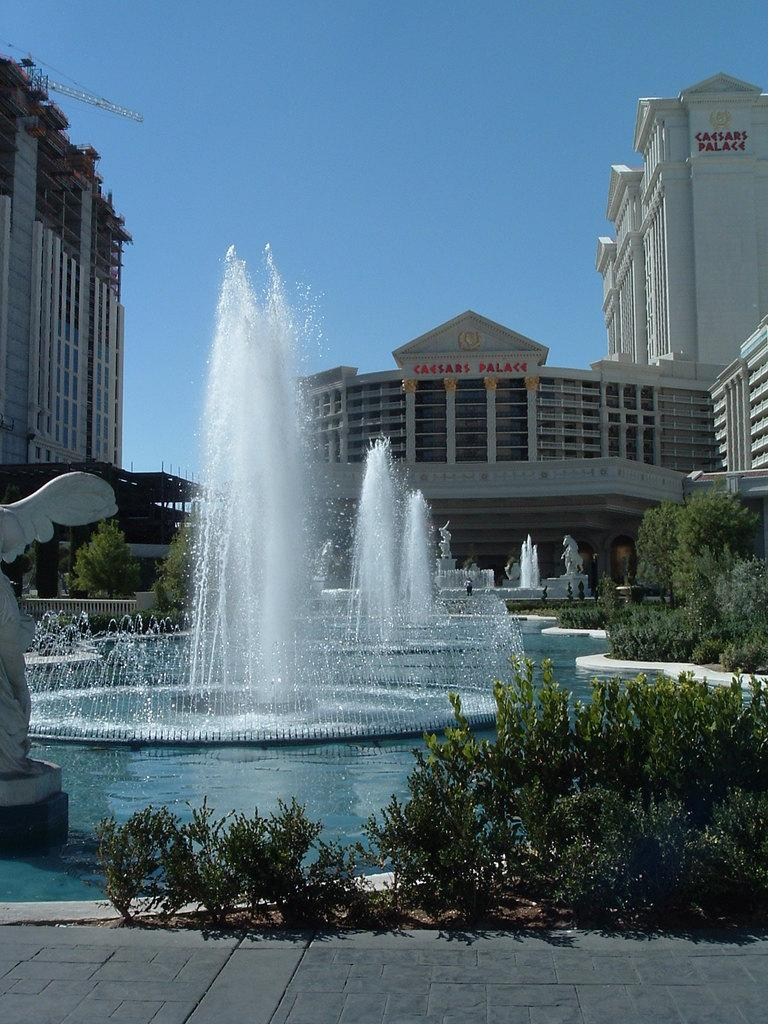What types of objects can be seen in the front portion of the image? A: In the front portion of the image, there are plants, statues, and water fountains. What can be found in the background of the image? In the background of the image, there are buildings and a crane tower. The sky is also visible. Can you describe the sky in the image? The sky is visible in the background of the image. Where is the grandmother sitting in the image? There is no grandmother present in the image. What type of badge can be seen on the statue in the image? There are no badges visible on any of the statues in the image. 